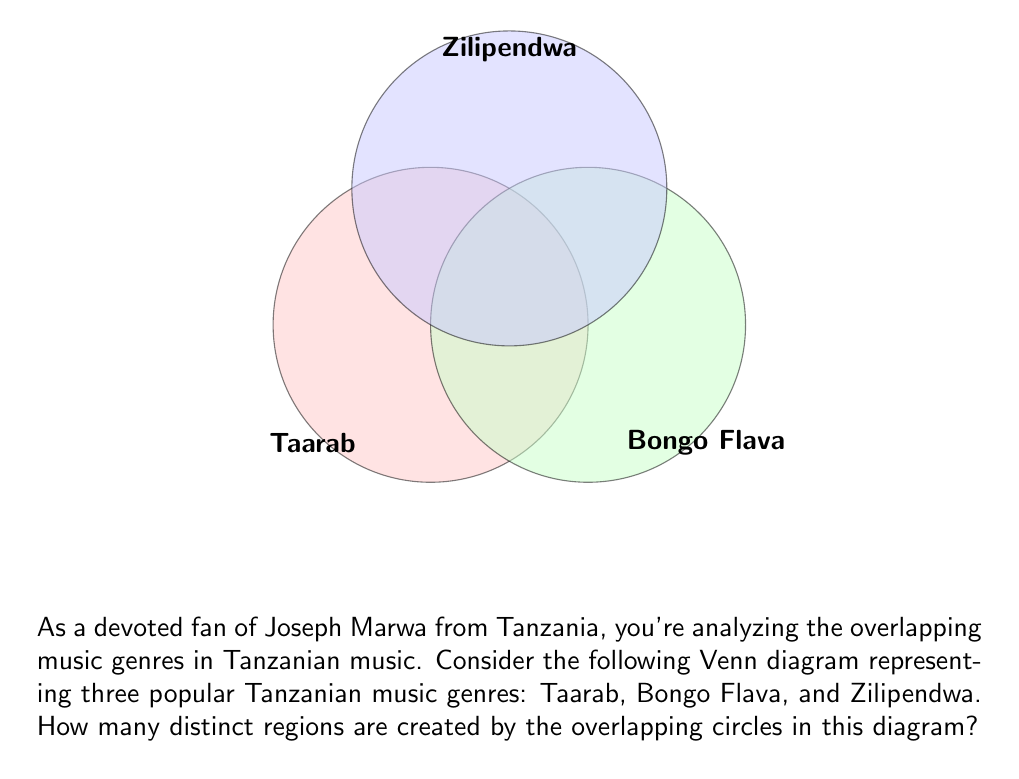Give your solution to this math problem. To count the number of distinct regions in a Venn diagram with three overlapping circles, we can use the following step-by-step approach:

1) First, recall that for $n$ circles, the maximum number of regions is given by the formula:

   $$2^n - 1$$

2) In this case, we have 3 circles, so the maximum number of regions is:

   $$2^3 - 1 = 8 - 1 = 7$$

3) Now, let's count each region:
   - 3 regions where each genre is unique (not overlapping)
   - 3 regions where two genres overlap
   - 1 region where all three genres overlap

4) We can verify that:

   $$3 + 3 + 1 = 7$$

This matches our calculation from step 2, confirming that all possible regions are present in the diagram.

5) Therefore, the number of distinct regions created by the overlapping circles in this Venn diagram is 7.

Each of these regions represents a unique combination of Tanzanian music genres, reflecting the rich and diverse musical landscape that artists like Joseph Marwa contribute to.
Answer: 7 